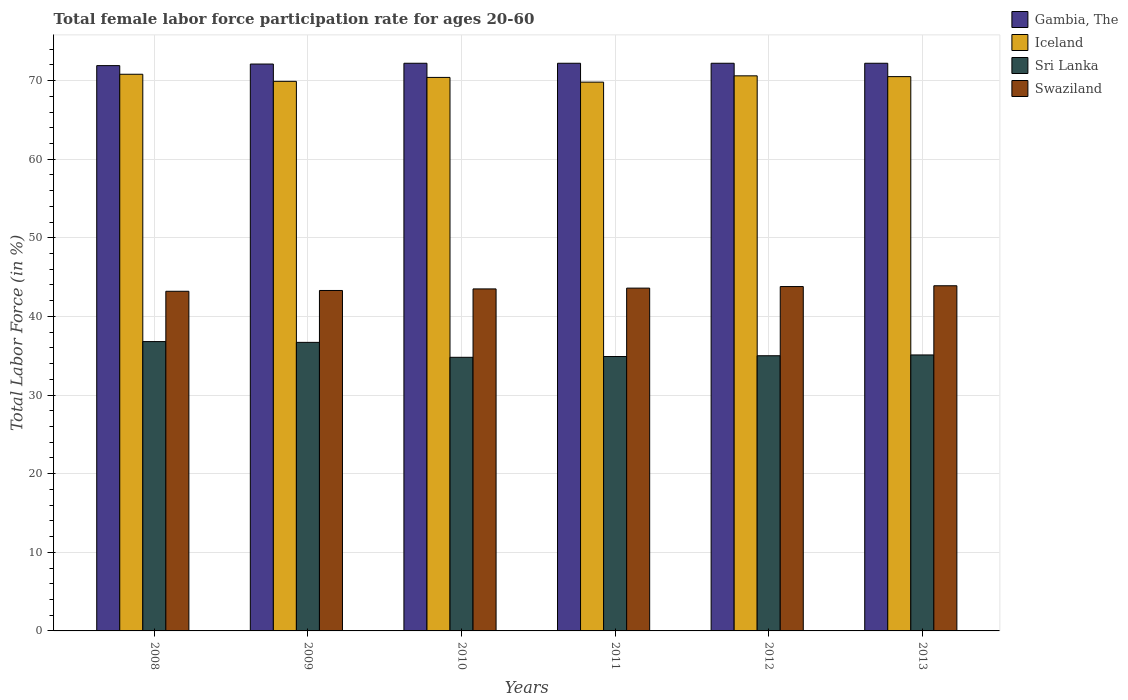How many different coloured bars are there?
Make the answer very short. 4. Are the number of bars per tick equal to the number of legend labels?
Make the answer very short. Yes. Are the number of bars on each tick of the X-axis equal?
Your response must be concise. Yes. How many bars are there on the 6th tick from the left?
Offer a very short reply. 4. How many bars are there on the 1st tick from the right?
Offer a terse response. 4. What is the label of the 6th group of bars from the left?
Give a very brief answer. 2013. What is the female labor force participation rate in Swaziland in 2013?
Keep it short and to the point. 43.9. Across all years, what is the maximum female labor force participation rate in Sri Lanka?
Your answer should be compact. 36.8. Across all years, what is the minimum female labor force participation rate in Sri Lanka?
Offer a terse response. 34.8. In which year was the female labor force participation rate in Sri Lanka maximum?
Your response must be concise. 2008. In which year was the female labor force participation rate in Swaziland minimum?
Offer a terse response. 2008. What is the total female labor force participation rate in Swaziland in the graph?
Your answer should be compact. 261.3. What is the difference between the female labor force participation rate in Gambia, The in 2009 and that in 2013?
Give a very brief answer. -0.1. What is the difference between the female labor force participation rate in Gambia, The in 2012 and the female labor force participation rate in Swaziland in 2013?
Provide a short and direct response. 28.3. What is the average female labor force participation rate in Swaziland per year?
Offer a very short reply. 43.55. In the year 2011, what is the difference between the female labor force participation rate in Swaziland and female labor force participation rate in Sri Lanka?
Give a very brief answer. 8.7. In how many years, is the female labor force participation rate in Iceland greater than 64 %?
Provide a short and direct response. 6. What is the ratio of the female labor force participation rate in Swaziland in 2008 to that in 2012?
Offer a very short reply. 0.99. Is the difference between the female labor force participation rate in Swaziland in 2011 and 2013 greater than the difference between the female labor force participation rate in Sri Lanka in 2011 and 2013?
Provide a succinct answer. No. What is the difference between the highest and the second highest female labor force participation rate in Iceland?
Your answer should be very brief. 0.2. What is the difference between the highest and the lowest female labor force participation rate in Gambia, The?
Ensure brevity in your answer.  0.3. In how many years, is the female labor force participation rate in Swaziland greater than the average female labor force participation rate in Swaziland taken over all years?
Keep it short and to the point. 3. What does the 3rd bar from the left in 2011 represents?
Keep it short and to the point. Sri Lanka. What does the 4th bar from the right in 2012 represents?
Offer a terse response. Gambia, The. Is it the case that in every year, the sum of the female labor force participation rate in Swaziland and female labor force participation rate in Iceland is greater than the female labor force participation rate in Gambia, The?
Offer a very short reply. Yes. How many bars are there?
Your answer should be compact. 24. Are all the bars in the graph horizontal?
Ensure brevity in your answer.  No. What is the title of the graph?
Your answer should be compact. Total female labor force participation rate for ages 20-60. What is the label or title of the X-axis?
Make the answer very short. Years. What is the Total Labor Force (in %) of Gambia, The in 2008?
Offer a very short reply. 71.9. What is the Total Labor Force (in %) in Iceland in 2008?
Provide a short and direct response. 70.8. What is the Total Labor Force (in %) in Sri Lanka in 2008?
Your response must be concise. 36.8. What is the Total Labor Force (in %) of Swaziland in 2008?
Give a very brief answer. 43.2. What is the Total Labor Force (in %) in Gambia, The in 2009?
Your response must be concise. 72.1. What is the Total Labor Force (in %) in Iceland in 2009?
Keep it short and to the point. 69.9. What is the Total Labor Force (in %) of Sri Lanka in 2009?
Your response must be concise. 36.7. What is the Total Labor Force (in %) of Swaziland in 2009?
Ensure brevity in your answer.  43.3. What is the Total Labor Force (in %) in Gambia, The in 2010?
Offer a very short reply. 72.2. What is the Total Labor Force (in %) in Iceland in 2010?
Give a very brief answer. 70.4. What is the Total Labor Force (in %) in Sri Lanka in 2010?
Provide a succinct answer. 34.8. What is the Total Labor Force (in %) in Swaziland in 2010?
Give a very brief answer. 43.5. What is the Total Labor Force (in %) of Gambia, The in 2011?
Your response must be concise. 72.2. What is the Total Labor Force (in %) in Iceland in 2011?
Provide a short and direct response. 69.8. What is the Total Labor Force (in %) in Sri Lanka in 2011?
Offer a terse response. 34.9. What is the Total Labor Force (in %) in Swaziland in 2011?
Your answer should be compact. 43.6. What is the Total Labor Force (in %) of Gambia, The in 2012?
Provide a short and direct response. 72.2. What is the Total Labor Force (in %) of Iceland in 2012?
Your response must be concise. 70.6. What is the Total Labor Force (in %) of Sri Lanka in 2012?
Keep it short and to the point. 35. What is the Total Labor Force (in %) of Swaziland in 2012?
Provide a short and direct response. 43.8. What is the Total Labor Force (in %) in Gambia, The in 2013?
Your answer should be compact. 72.2. What is the Total Labor Force (in %) of Iceland in 2013?
Keep it short and to the point. 70.5. What is the Total Labor Force (in %) of Sri Lanka in 2013?
Offer a terse response. 35.1. What is the Total Labor Force (in %) in Swaziland in 2013?
Offer a very short reply. 43.9. Across all years, what is the maximum Total Labor Force (in %) in Gambia, The?
Keep it short and to the point. 72.2. Across all years, what is the maximum Total Labor Force (in %) in Iceland?
Your answer should be compact. 70.8. Across all years, what is the maximum Total Labor Force (in %) of Sri Lanka?
Ensure brevity in your answer.  36.8. Across all years, what is the maximum Total Labor Force (in %) in Swaziland?
Give a very brief answer. 43.9. Across all years, what is the minimum Total Labor Force (in %) in Gambia, The?
Your answer should be compact. 71.9. Across all years, what is the minimum Total Labor Force (in %) of Iceland?
Offer a very short reply. 69.8. Across all years, what is the minimum Total Labor Force (in %) of Sri Lanka?
Keep it short and to the point. 34.8. Across all years, what is the minimum Total Labor Force (in %) in Swaziland?
Offer a very short reply. 43.2. What is the total Total Labor Force (in %) of Gambia, The in the graph?
Ensure brevity in your answer.  432.8. What is the total Total Labor Force (in %) of Iceland in the graph?
Offer a terse response. 422. What is the total Total Labor Force (in %) in Sri Lanka in the graph?
Offer a very short reply. 213.3. What is the total Total Labor Force (in %) in Swaziland in the graph?
Provide a succinct answer. 261.3. What is the difference between the Total Labor Force (in %) of Iceland in 2008 and that in 2009?
Provide a short and direct response. 0.9. What is the difference between the Total Labor Force (in %) of Sri Lanka in 2008 and that in 2011?
Offer a terse response. 1.9. What is the difference between the Total Labor Force (in %) of Swaziland in 2008 and that in 2011?
Your response must be concise. -0.4. What is the difference between the Total Labor Force (in %) in Sri Lanka in 2008 and that in 2012?
Provide a succinct answer. 1.8. What is the difference between the Total Labor Force (in %) of Swaziland in 2008 and that in 2012?
Offer a terse response. -0.6. What is the difference between the Total Labor Force (in %) of Iceland in 2009 and that in 2010?
Offer a terse response. -0.5. What is the difference between the Total Labor Force (in %) of Sri Lanka in 2009 and that in 2010?
Your answer should be compact. 1.9. What is the difference between the Total Labor Force (in %) of Swaziland in 2009 and that in 2010?
Your response must be concise. -0.2. What is the difference between the Total Labor Force (in %) of Gambia, The in 2009 and that in 2011?
Your answer should be compact. -0.1. What is the difference between the Total Labor Force (in %) in Iceland in 2009 and that in 2011?
Keep it short and to the point. 0.1. What is the difference between the Total Labor Force (in %) of Sri Lanka in 2009 and that in 2011?
Your answer should be very brief. 1.8. What is the difference between the Total Labor Force (in %) of Swaziland in 2009 and that in 2011?
Give a very brief answer. -0.3. What is the difference between the Total Labor Force (in %) of Iceland in 2009 and that in 2012?
Your answer should be compact. -0.7. What is the difference between the Total Labor Force (in %) in Sri Lanka in 2009 and that in 2012?
Make the answer very short. 1.7. What is the difference between the Total Labor Force (in %) in Gambia, The in 2009 and that in 2013?
Offer a terse response. -0.1. What is the difference between the Total Labor Force (in %) in Gambia, The in 2010 and that in 2011?
Keep it short and to the point. 0. What is the difference between the Total Labor Force (in %) in Iceland in 2010 and that in 2011?
Give a very brief answer. 0.6. What is the difference between the Total Labor Force (in %) in Swaziland in 2010 and that in 2011?
Give a very brief answer. -0.1. What is the difference between the Total Labor Force (in %) in Iceland in 2010 and that in 2013?
Your response must be concise. -0.1. What is the difference between the Total Labor Force (in %) in Sri Lanka in 2010 and that in 2013?
Your answer should be very brief. -0.3. What is the difference between the Total Labor Force (in %) in Swaziland in 2011 and that in 2012?
Provide a short and direct response. -0.2. What is the difference between the Total Labor Force (in %) in Iceland in 2011 and that in 2013?
Your answer should be very brief. -0.7. What is the difference between the Total Labor Force (in %) of Sri Lanka in 2011 and that in 2013?
Your answer should be very brief. -0.2. What is the difference between the Total Labor Force (in %) of Swaziland in 2011 and that in 2013?
Your response must be concise. -0.3. What is the difference between the Total Labor Force (in %) of Gambia, The in 2012 and that in 2013?
Keep it short and to the point. 0. What is the difference between the Total Labor Force (in %) of Iceland in 2012 and that in 2013?
Give a very brief answer. 0.1. What is the difference between the Total Labor Force (in %) in Sri Lanka in 2012 and that in 2013?
Make the answer very short. -0.1. What is the difference between the Total Labor Force (in %) of Gambia, The in 2008 and the Total Labor Force (in %) of Sri Lanka in 2009?
Your answer should be compact. 35.2. What is the difference between the Total Labor Force (in %) in Gambia, The in 2008 and the Total Labor Force (in %) in Swaziland in 2009?
Offer a terse response. 28.6. What is the difference between the Total Labor Force (in %) of Iceland in 2008 and the Total Labor Force (in %) of Sri Lanka in 2009?
Ensure brevity in your answer.  34.1. What is the difference between the Total Labor Force (in %) in Sri Lanka in 2008 and the Total Labor Force (in %) in Swaziland in 2009?
Provide a succinct answer. -6.5. What is the difference between the Total Labor Force (in %) in Gambia, The in 2008 and the Total Labor Force (in %) in Iceland in 2010?
Offer a very short reply. 1.5. What is the difference between the Total Labor Force (in %) in Gambia, The in 2008 and the Total Labor Force (in %) in Sri Lanka in 2010?
Provide a succinct answer. 37.1. What is the difference between the Total Labor Force (in %) of Gambia, The in 2008 and the Total Labor Force (in %) of Swaziland in 2010?
Offer a terse response. 28.4. What is the difference between the Total Labor Force (in %) of Iceland in 2008 and the Total Labor Force (in %) of Sri Lanka in 2010?
Your answer should be very brief. 36. What is the difference between the Total Labor Force (in %) of Iceland in 2008 and the Total Labor Force (in %) of Swaziland in 2010?
Keep it short and to the point. 27.3. What is the difference between the Total Labor Force (in %) of Gambia, The in 2008 and the Total Labor Force (in %) of Sri Lanka in 2011?
Offer a very short reply. 37. What is the difference between the Total Labor Force (in %) of Gambia, The in 2008 and the Total Labor Force (in %) of Swaziland in 2011?
Ensure brevity in your answer.  28.3. What is the difference between the Total Labor Force (in %) of Iceland in 2008 and the Total Labor Force (in %) of Sri Lanka in 2011?
Keep it short and to the point. 35.9. What is the difference between the Total Labor Force (in %) of Iceland in 2008 and the Total Labor Force (in %) of Swaziland in 2011?
Provide a succinct answer. 27.2. What is the difference between the Total Labor Force (in %) in Gambia, The in 2008 and the Total Labor Force (in %) in Iceland in 2012?
Offer a very short reply. 1.3. What is the difference between the Total Labor Force (in %) in Gambia, The in 2008 and the Total Labor Force (in %) in Sri Lanka in 2012?
Provide a short and direct response. 36.9. What is the difference between the Total Labor Force (in %) of Gambia, The in 2008 and the Total Labor Force (in %) of Swaziland in 2012?
Your answer should be compact. 28.1. What is the difference between the Total Labor Force (in %) in Iceland in 2008 and the Total Labor Force (in %) in Sri Lanka in 2012?
Provide a short and direct response. 35.8. What is the difference between the Total Labor Force (in %) in Iceland in 2008 and the Total Labor Force (in %) in Swaziland in 2012?
Offer a very short reply. 27. What is the difference between the Total Labor Force (in %) of Gambia, The in 2008 and the Total Labor Force (in %) of Sri Lanka in 2013?
Give a very brief answer. 36.8. What is the difference between the Total Labor Force (in %) in Iceland in 2008 and the Total Labor Force (in %) in Sri Lanka in 2013?
Make the answer very short. 35.7. What is the difference between the Total Labor Force (in %) in Iceland in 2008 and the Total Labor Force (in %) in Swaziland in 2013?
Your answer should be very brief. 26.9. What is the difference between the Total Labor Force (in %) in Sri Lanka in 2008 and the Total Labor Force (in %) in Swaziland in 2013?
Your answer should be very brief. -7.1. What is the difference between the Total Labor Force (in %) in Gambia, The in 2009 and the Total Labor Force (in %) in Sri Lanka in 2010?
Your answer should be compact. 37.3. What is the difference between the Total Labor Force (in %) of Gambia, The in 2009 and the Total Labor Force (in %) of Swaziland in 2010?
Your response must be concise. 28.6. What is the difference between the Total Labor Force (in %) in Iceland in 2009 and the Total Labor Force (in %) in Sri Lanka in 2010?
Your response must be concise. 35.1. What is the difference between the Total Labor Force (in %) of Iceland in 2009 and the Total Labor Force (in %) of Swaziland in 2010?
Provide a short and direct response. 26.4. What is the difference between the Total Labor Force (in %) of Gambia, The in 2009 and the Total Labor Force (in %) of Iceland in 2011?
Your response must be concise. 2.3. What is the difference between the Total Labor Force (in %) of Gambia, The in 2009 and the Total Labor Force (in %) of Sri Lanka in 2011?
Offer a very short reply. 37.2. What is the difference between the Total Labor Force (in %) in Iceland in 2009 and the Total Labor Force (in %) in Swaziland in 2011?
Keep it short and to the point. 26.3. What is the difference between the Total Labor Force (in %) in Sri Lanka in 2009 and the Total Labor Force (in %) in Swaziland in 2011?
Provide a succinct answer. -6.9. What is the difference between the Total Labor Force (in %) of Gambia, The in 2009 and the Total Labor Force (in %) of Iceland in 2012?
Ensure brevity in your answer.  1.5. What is the difference between the Total Labor Force (in %) in Gambia, The in 2009 and the Total Labor Force (in %) in Sri Lanka in 2012?
Keep it short and to the point. 37.1. What is the difference between the Total Labor Force (in %) of Gambia, The in 2009 and the Total Labor Force (in %) of Swaziland in 2012?
Offer a very short reply. 28.3. What is the difference between the Total Labor Force (in %) of Iceland in 2009 and the Total Labor Force (in %) of Sri Lanka in 2012?
Give a very brief answer. 34.9. What is the difference between the Total Labor Force (in %) in Iceland in 2009 and the Total Labor Force (in %) in Swaziland in 2012?
Your response must be concise. 26.1. What is the difference between the Total Labor Force (in %) of Gambia, The in 2009 and the Total Labor Force (in %) of Swaziland in 2013?
Keep it short and to the point. 28.2. What is the difference between the Total Labor Force (in %) of Iceland in 2009 and the Total Labor Force (in %) of Sri Lanka in 2013?
Make the answer very short. 34.8. What is the difference between the Total Labor Force (in %) of Gambia, The in 2010 and the Total Labor Force (in %) of Iceland in 2011?
Keep it short and to the point. 2.4. What is the difference between the Total Labor Force (in %) in Gambia, The in 2010 and the Total Labor Force (in %) in Sri Lanka in 2011?
Your answer should be compact. 37.3. What is the difference between the Total Labor Force (in %) in Gambia, The in 2010 and the Total Labor Force (in %) in Swaziland in 2011?
Provide a short and direct response. 28.6. What is the difference between the Total Labor Force (in %) of Iceland in 2010 and the Total Labor Force (in %) of Sri Lanka in 2011?
Give a very brief answer. 35.5. What is the difference between the Total Labor Force (in %) of Iceland in 2010 and the Total Labor Force (in %) of Swaziland in 2011?
Offer a terse response. 26.8. What is the difference between the Total Labor Force (in %) of Sri Lanka in 2010 and the Total Labor Force (in %) of Swaziland in 2011?
Make the answer very short. -8.8. What is the difference between the Total Labor Force (in %) of Gambia, The in 2010 and the Total Labor Force (in %) of Sri Lanka in 2012?
Your response must be concise. 37.2. What is the difference between the Total Labor Force (in %) in Gambia, The in 2010 and the Total Labor Force (in %) in Swaziland in 2012?
Offer a terse response. 28.4. What is the difference between the Total Labor Force (in %) in Iceland in 2010 and the Total Labor Force (in %) in Sri Lanka in 2012?
Your answer should be very brief. 35.4. What is the difference between the Total Labor Force (in %) in Iceland in 2010 and the Total Labor Force (in %) in Swaziland in 2012?
Provide a succinct answer. 26.6. What is the difference between the Total Labor Force (in %) in Gambia, The in 2010 and the Total Labor Force (in %) in Sri Lanka in 2013?
Your answer should be compact. 37.1. What is the difference between the Total Labor Force (in %) in Gambia, The in 2010 and the Total Labor Force (in %) in Swaziland in 2013?
Give a very brief answer. 28.3. What is the difference between the Total Labor Force (in %) of Iceland in 2010 and the Total Labor Force (in %) of Sri Lanka in 2013?
Offer a very short reply. 35.3. What is the difference between the Total Labor Force (in %) in Sri Lanka in 2010 and the Total Labor Force (in %) in Swaziland in 2013?
Your answer should be very brief. -9.1. What is the difference between the Total Labor Force (in %) in Gambia, The in 2011 and the Total Labor Force (in %) in Sri Lanka in 2012?
Make the answer very short. 37.2. What is the difference between the Total Labor Force (in %) of Gambia, The in 2011 and the Total Labor Force (in %) of Swaziland in 2012?
Provide a succinct answer. 28.4. What is the difference between the Total Labor Force (in %) in Iceland in 2011 and the Total Labor Force (in %) in Sri Lanka in 2012?
Provide a succinct answer. 34.8. What is the difference between the Total Labor Force (in %) in Gambia, The in 2011 and the Total Labor Force (in %) in Iceland in 2013?
Offer a very short reply. 1.7. What is the difference between the Total Labor Force (in %) of Gambia, The in 2011 and the Total Labor Force (in %) of Sri Lanka in 2013?
Provide a succinct answer. 37.1. What is the difference between the Total Labor Force (in %) of Gambia, The in 2011 and the Total Labor Force (in %) of Swaziland in 2013?
Give a very brief answer. 28.3. What is the difference between the Total Labor Force (in %) of Iceland in 2011 and the Total Labor Force (in %) of Sri Lanka in 2013?
Offer a terse response. 34.7. What is the difference between the Total Labor Force (in %) in Iceland in 2011 and the Total Labor Force (in %) in Swaziland in 2013?
Offer a terse response. 25.9. What is the difference between the Total Labor Force (in %) of Sri Lanka in 2011 and the Total Labor Force (in %) of Swaziland in 2013?
Offer a terse response. -9. What is the difference between the Total Labor Force (in %) of Gambia, The in 2012 and the Total Labor Force (in %) of Iceland in 2013?
Provide a short and direct response. 1.7. What is the difference between the Total Labor Force (in %) in Gambia, The in 2012 and the Total Labor Force (in %) in Sri Lanka in 2013?
Your answer should be very brief. 37.1. What is the difference between the Total Labor Force (in %) in Gambia, The in 2012 and the Total Labor Force (in %) in Swaziland in 2013?
Make the answer very short. 28.3. What is the difference between the Total Labor Force (in %) of Iceland in 2012 and the Total Labor Force (in %) of Sri Lanka in 2013?
Offer a very short reply. 35.5. What is the difference between the Total Labor Force (in %) in Iceland in 2012 and the Total Labor Force (in %) in Swaziland in 2013?
Make the answer very short. 26.7. What is the average Total Labor Force (in %) in Gambia, The per year?
Offer a very short reply. 72.13. What is the average Total Labor Force (in %) of Iceland per year?
Provide a short and direct response. 70.33. What is the average Total Labor Force (in %) in Sri Lanka per year?
Keep it short and to the point. 35.55. What is the average Total Labor Force (in %) of Swaziland per year?
Offer a very short reply. 43.55. In the year 2008, what is the difference between the Total Labor Force (in %) in Gambia, The and Total Labor Force (in %) in Sri Lanka?
Give a very brief answer. 35.1. In the year 2008, what is the difference between the Total Labor Force (in %) of Gambia, The and Total Labor Force (in %) of Swaziland?
Your response must be concise. 28.7. In the year 2008, what is the difference between the Total Labor Force (in %) of Iceland and Total Labor Force (in %) of Swaziland?
Offer a very short reply. 27.6. In the year 2009, what is the difference between the Total Labor Force (in %) of Gambia, The and Total Labor Force (in %) of Sri Lanka?
Provide a short and direct response. 35.4. In the year 2009, what is the difference between the Total Labor Force (in %) in Gambia, The and Total Labor Force (in %) in Swaziland?
Your response must be concise. 28.8. In the year 2009, what is the difference between the Total Labor Force (in %) of Iceland and Total Labor Force (in %) of Sri Lanka?
Make the answer very short. 33.2. In the year 2009, what is the difference between the Total Labor Force (in %) of Iceland and Total Labor Force (in %) of Swaziland?
Keep it short and to the point. 26.6. In the year 2010, what is the difference between the Total Labor Force (in %) in Gambia, The and Total Labor Force (in %) in Iceland?
Offer a very short reply. 1.8. In the year 2010, what is the difference between the Total Labor Force (in %) of Gambia, The and Total Labor Force (in %) of Sri Lanka?
Make the answer very short. 37.4. In the year 2010, what is the difference between the Total Labor Force (in %) of Gambia, The and Total Labor Force (in %) of Swaziland?
Your answer should be compact. 28.7. In the year 2010, what is the difference between the Total Labor Force (in %) of Iceland and Total Labor Force (in %) of Sri Lanka?
Ensure brevity in your answer.  35.6. In the year 2010, what is the difference between the Total Labor Force (in %) in Iceland and Total Labor Force (in %) in Swaziland?
Provide a succinct answer. 26.9. In the year 2010, what is the difference between the Total Labor Force (in %) in Sri Lanka and Total Labor Force (in %) in Swaziland?
Make the answer very short. -8.7. In the year 2011, what is the difference between the Total Labor Force (in %) in Gambia, The and Total Labor Force (in %) in Iceland?
Offer a very short reply. 2.4. In the year 2011, what is the difference between the Total Labor Force (in %) of Gambia, The and Total Labor Force (in %) of Sri Lanka?
Make the answer very short. 37.3. In the year 2011, what is the difference between the Total Labor Force (in %) in Gambia, The and Total Labor Force (in %) in Swaziland?
Your answer should be compact. 28.6. In the year 2011, what is the difference between the Total Labor Force (in %) in Iceland and Total Labor Force (in %) in Sri Lanka?
Offer a terse response. 34.9. In the year 2011, what is the difference between the Total Labor Force (in %) of Iceland and Total Labor Force (in %) of Swaziland?
Keep it short and to the point. 26.2. In the year 2012, what is the difference between the Total Labor Force (in %) in Gambia, The and Total Labor Force (in %) in Iceland?
Your response must be concise. 1.6. In the year 2012, what is the difference between the Total Labor Force (in %) of Gambia, The and Total Labor Force (in %) of Sri Lanka?
Offer a very short reply. 37.2. In the year 2012, what is the difference between the Total Labor Force (in %) of Gambia, The and Total Labor Force (in %) of Swaziland?
Give a very brief answer. 28.4. In the year 2012, what is the difference between the Total Labor Force (in %) of Iceland and Total Labor Force (in %) of Sri Lanka?
Your answer should be compact. 35.6. In the year 2012, what is the difference between the Total Labor Force (in %) of Iceland and Total Labor Force (in %) of Swaziland?
Keep it short and to the point. 26.8. In the year 2012, what is the difference between the Total Labor Force (in %) in Sri Lanka and Total Labor Force (in %) in Swaziland?
Your answer should be compact. -8.8. In the year 2013, what is the difference between the Total Labor Force (in %) in Gambia, The and Total Labor Force (in %) in Iceland?
Your answer should be compact. 1.7. In the year 2013, what is the difference between the Total Labor Force (in %) in Gambia, The and Total Labor Force (in %) in Sri Lanka?
Offer a very short reply. 37.1. In the year 2013, what is the difference between the Total Labor Force (in %) of Gambia, The and Total Labor Force (in %) of Swaziland?
Give a very brief answer. 28.3. In the year 2013, what is the difference between the Total Labor Force (in %) of Iceland and Total Labor Force (in %) of Sri Lanka?
Offer a terse response. 35.4. In the year 2013, what is the difference between the Total Labor Force (in %) in Iceland and Total Labor Force (in %) in Swaziland?
Offer a very short reply. 26.6. What is the ratio of the Total Labor Force (in %) in Gambia, The in 2008 to that in 2009?
Provide a succinct answer. 1. What is the ratio of the Total Labor Force (in %) of Iceland in 2008 to that in 2009?
Offer a very short reply. 1.01. What is the ratio of the Total Labor Force (in %) of Swaziland in 2008 to that in 2009?
Your response must be concise. 1. What is the ratio of the Total Labor Force (in %) in Gambia, The in 2008 to that in 2010?
Make the answer very short. 1. What is the ratio of the Total Labor Force (in %) of Sri Lanka in 2008 to that in 2010?
Offer a very short reply. 1.06. What is the ratio of the Total Labor Force (in %) of Swaziland in 2008 to that in 2010?
Give a very brief answer. 0.99. What is the ratio of the Total Labor Force (in %) of Iceland in 2008 to that in 2011?
Your answer should be very brief. 1.01. What is the ratio of the Total Labor Force (in %) of Sri Lanka in 2008 to that in 2011?
Provide a short and direct response. 1.05. What is the ratio of the Total Labor Force (in %) in Gambia, The in 2008 to that in 2012?
Make the answer very short. 1. What is the ratio of the Total Labor Force (in %) of Sri Lanka in 2008 to that in 2012?
Provide a succinct answer. 1.05. What is the ratio of the Total Labor Force (in %) in Swaziland in 2008 to that in 2012?
Keep it short and to the point. 0.99. What is the ratio of the Total Labor Force (in %) in Gambia, The in 2008 to that in 2013?
Provide a succinct answer. 1. What is the ratio of the Total Labor Force (in %) of Iceland in 2008 to that in 2013?
Your response must be concise. 1. What is the ratio of the Total Labor Force (in %) of Sri Lanka in 2008 to that in 2013?
Give a very brief answer. 1.05. What is the ratio of the Total Labor Force (in %) of Swaziland in 2008 to that in 2013?
Your answer should be compact. 0.98. What is the ratio of the Total Labor Force (in %) in Sri Lanka in 2009 to that in 2010?
Your response must be concise. 1.05. What is the ratio of the Total Labor Force (in %) in Swaziland in 2009 to that in 2010?
Your answer should be very brief. 1. What is the ratio of the Total Labor Force (in %) of Iceland in 2009 to that in 2011?
Make the answer very short. 1. What is the ratio of the Total Labor Force (in %) of Sri Lanka in 2009 to that in 2011?
Offer a very short reply. 1.05. What is the ratio of the Total Labor Force (in %) in Iceland in 2009 to that in 2012?
Keep it short and to the point. 0.99. What is the ratio of the Total Labor Force (in %) of Sri Lanka in 2009 to that in 2012?
Your response must be concise. 1.05. What is the ratio of the Total Labor Force (in %) in Gambia, The in 2009 to that in 2013?
Give a very brief answer. 1. What is the ratio of the Total Labor Force (in %) of Sri Lanka in 2009 to that in 2013?
Offer a terse response. 1.05. What is the ratio of the Total Labor Force (in %) in Swaziland in 2009 to that in 2013?
Your answer should be very brief. 0.99. What is the ratio of the Total Labor Force (in %) in Gambia, The in 2010 to that in 2011?
Ensure brevity in your answer.  1. What is the ratio of the Total Labor Force (in %) in Iceland in 2010 to that in 2011?
Your answer should be compact. 1.01. What is the ratio of the Total Labor Force (in %) in Swaziland in 2010 to that in 2011?
Provide a succinct answer. 1. What is the ratio of the Total Labor Force (in %) in Swaziland in 2010 to that in 2012?
Ensure brevity in your answer.  0.99. What is the ratio of the Total Labor Force (in %) in Sri Lanka in 2010 to that in 2013?
Your response must be concise. 0.99. What is the ratio of the Total Labor Force (in %) in Swaziland in 2010 to that in 2013?
Make the answer very short. 0.99. What is the ratio of the Total Labor Force (in %) in Gambia, The in 2011 to that in 2012?
Ensure brevity in your answer.  1. What is the ratio of the Total Labor Force (in %) of Iceland in 2011 to that in 2012?
Your response must be concise. 0.99. What is the ratio of the Total Labor Force (in %) of Sri Lanka in 2011 to that in 2012?
Your response must be concise. 1. What is the ratio of the Total Labor Force (in %) of Swaziland in 2011 to that in 2012?
Give a very brief answer. 1. What is the ratio of the Total Labor Force (in %) in Swaziland in 2011 to that in 2013?
Your answer should be very brief. 0.99. What is the ratio of the Total Labor Force (in %) of Gambia, The in 2012 to that in 2013?
Offer a very short reply. 1. What is the ratio of the Total Labor Force (in %) in Swaziland in 2012 to that in 2013?
Provide a short and direct response. 1. What is the difference between the highest and the second highest Total Labor Force (in %) in Sri Lanka?
Make the answer very short. 0.1. What is the difference between the highest and the second highest Total Labor Force (in %) of Swaziland?
Keep it short and to the point. 0.1. 